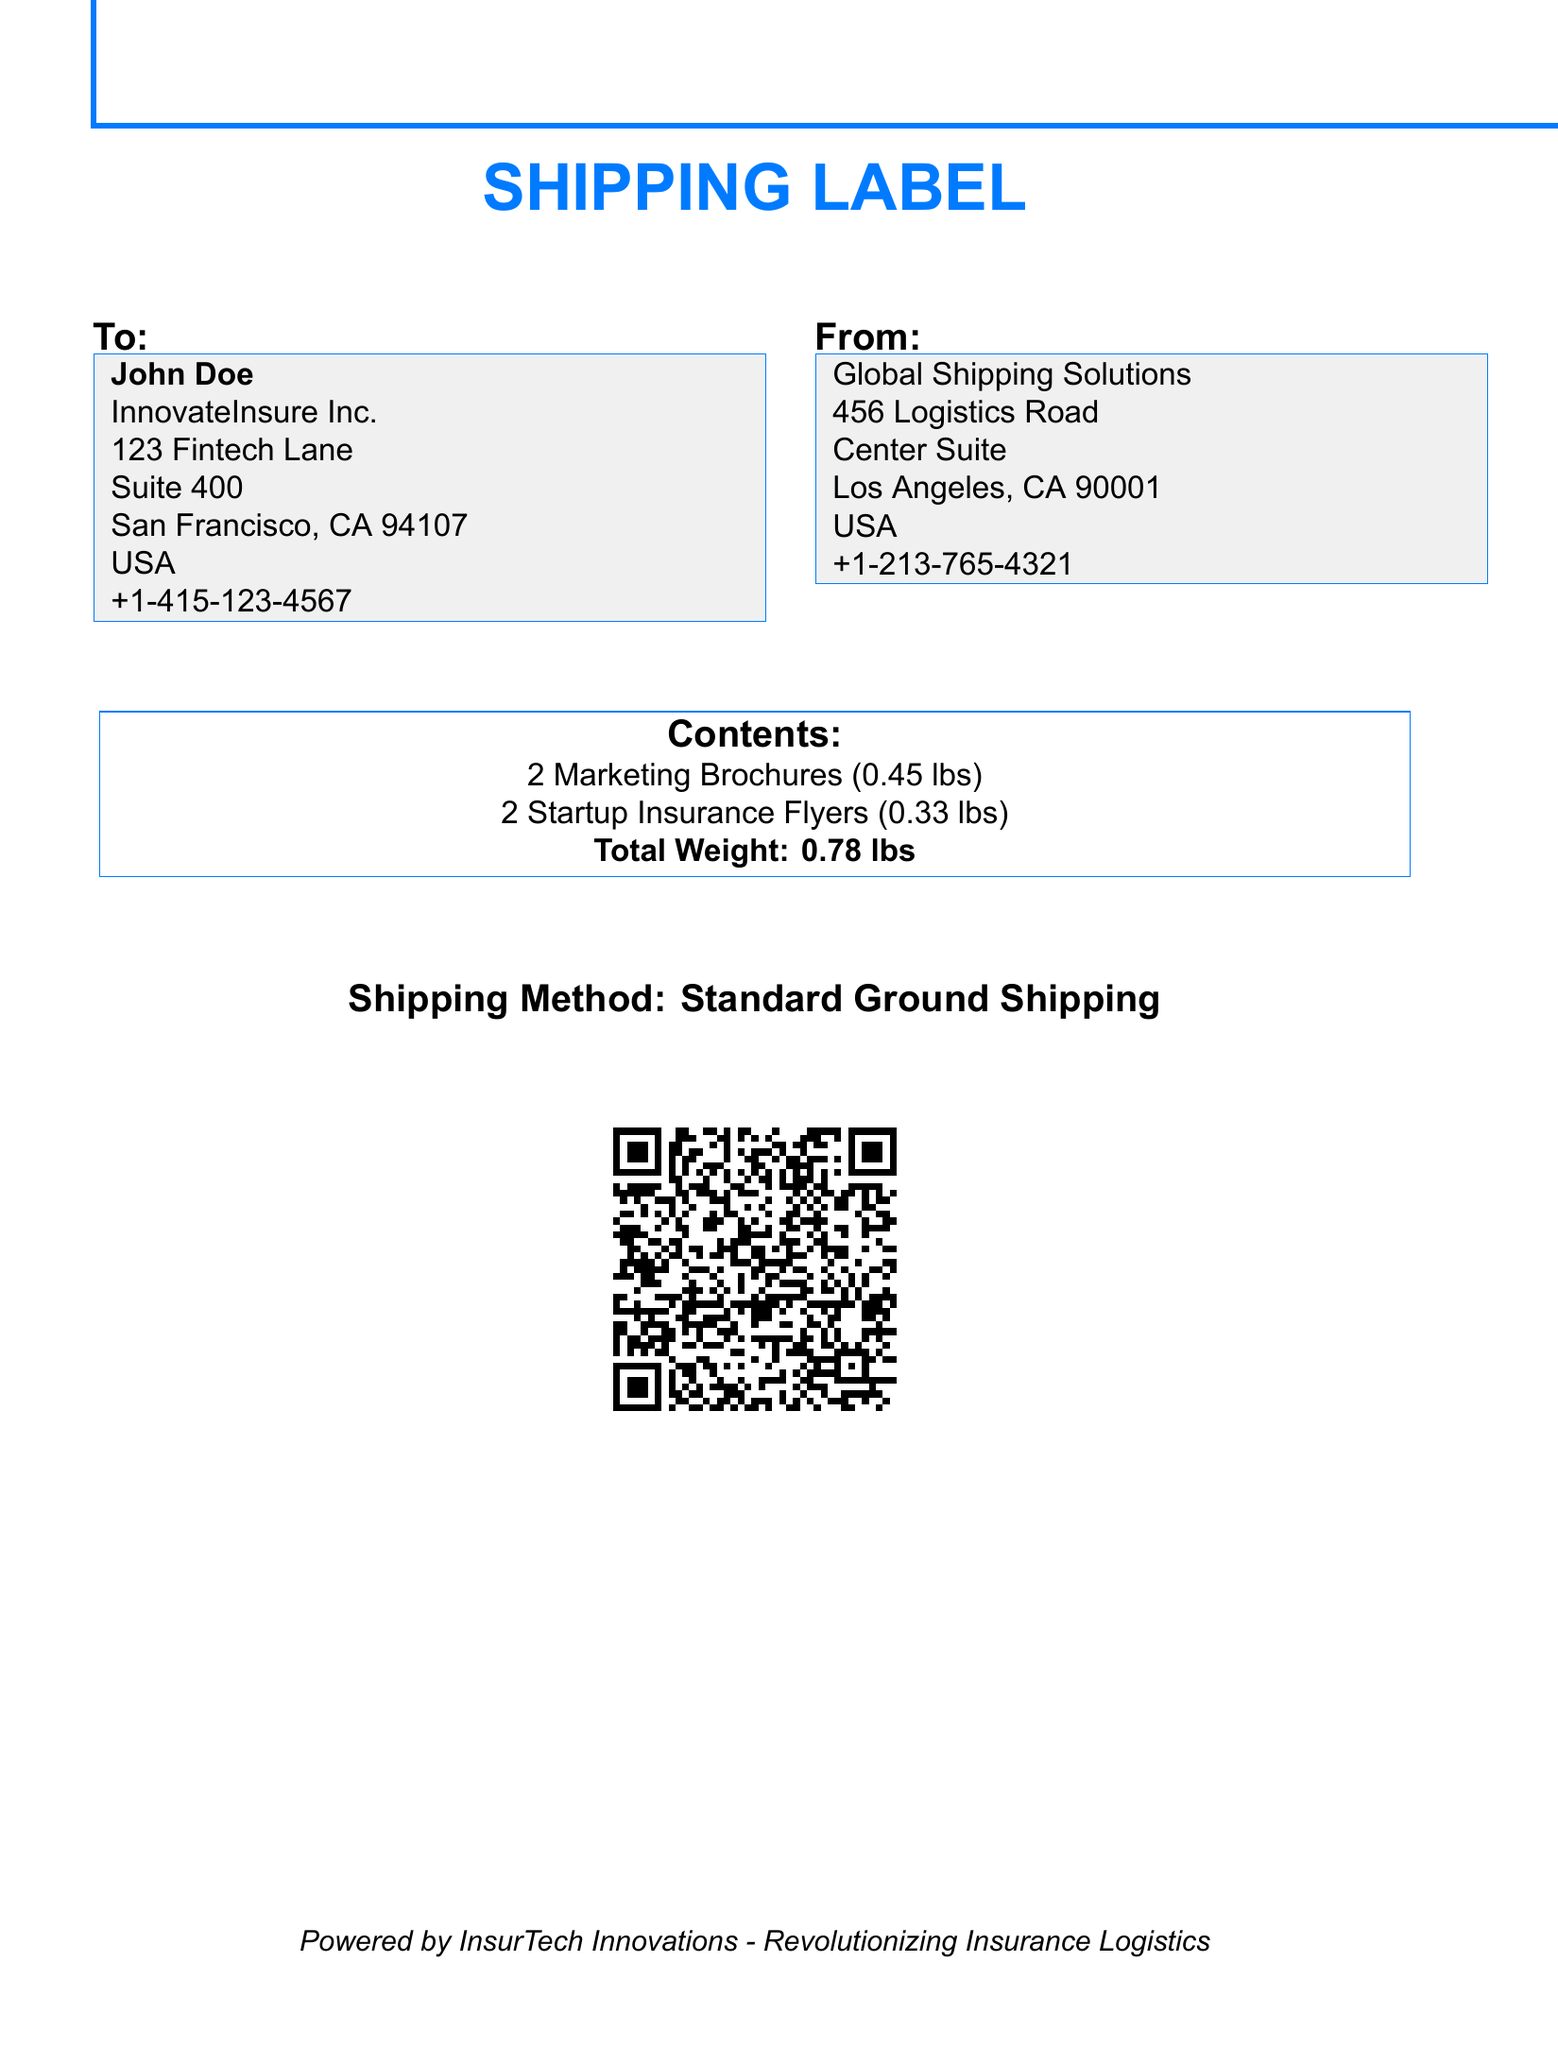What is the name of the recipient? The recipient's name is clearly stated in the "To" section of the document, which is John Doe.
Answer: John Doe What company is the recipient associated with? The document specifies that the recipient is associated with InnovateInsure Inc. in the "To" section.
Answer: InnovateInsure Inc What is the total weight of the contents? The total weight is calculated and stated in the contents section of the document as 0.78 lbs.
Answer: 0.78 lbs How many marketing brochures are included? The number of marketing brochures is listed in the contents section, indicating that there are 2 marketing brochures.
Answer: 2 Marketing Brochures What type of shipping method is used? The shipping method is explicitly mentioned in the document and is stated to be "Standard Ground Shipping."
Answer: Standard Ground Shipping What is the address of the sender? The sender's address is provided in the "From" section, which is Global Shipping Solutions, 456 Logistics Road, Center Suite, Los Angeles, CA 90001, USA.
Answer: Global Shipping Solutions, 456 Logistics Road, Center Suite, Los Angeles, CA 90001, USA How many startup insurance flyers are being shipped? The document specifies that there are 2 startup insurance flyers included in the shipment.
Answer: 2 Startup Insurance Flyers What is the phone number of the recipient? The recipient's phone number is listed in the "To" section as +1-415-123-4567.
Answer: +1-415-123-4567 What is the QR code used for? The QR code contains shipping information for the recipient, including their name and address, which aids in logistics.
Answer: Shipping information What is the theme color used in the shipping label? The theme color used in the shipping label, as seen in the border and text, is described as insurtech color with RGB values.
Answer: Insurtech (RGB: 0,123,255) 